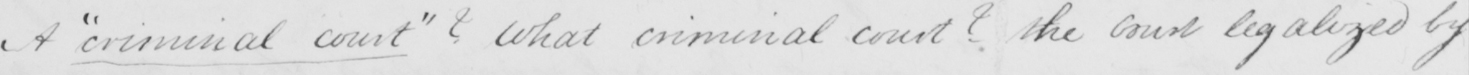Please provide the text content of this handwritten line. A  " criminal court "  ?  What criminal court ?  the court legalized by 